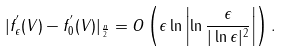<formula> <loc_0><loc_0><loc_500><loc_500>| f ^ { ^ { \prime } } _ { \epsilon } ( V ) - f ^ { ^ { \prime } } _ { 0 } ( V ) | _ { \frac { n } { 2 } } = O \left ( \epsilon \ln \left | \ln \frac { \epsilon } { | \ln \epsilon | ^ { 2 } } \right | \right ) .</formula> 